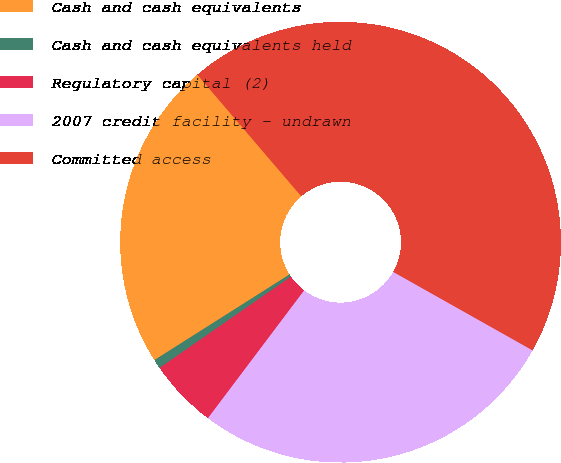Convert chart. <chart><loc_0><loc_0><loc_500><loc_500><pie_chart><fcel>Cash and cash equivalents<fcel>Cash and cash equivalents held<fcel>Regulatory capital (2)<fcel>2007 credit facility - undrawn<fcel>Committed access<nl><fcel>22.73%<fcel>0.68%<fcel>5.06%<fcel>27.11%<fcel>44.42%<nl></chart> 